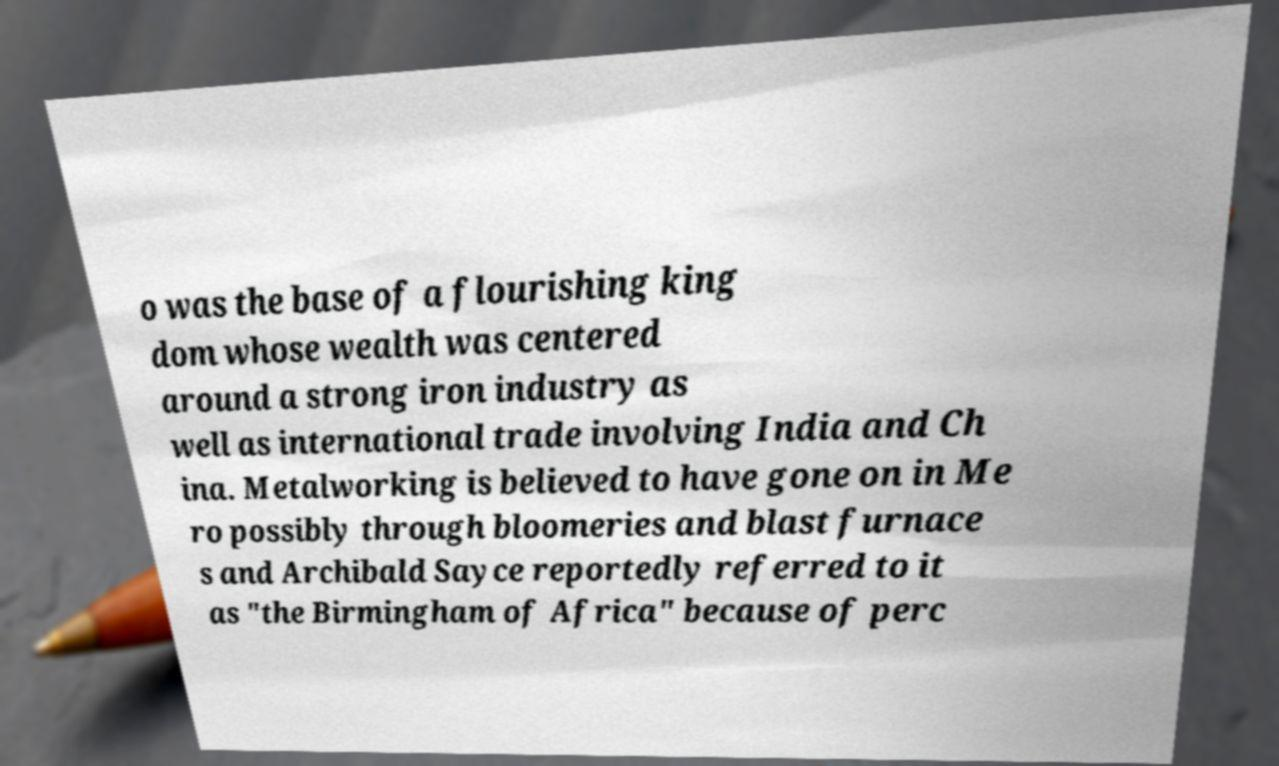Please identify and transcribe the text found in this image. o was the base of a flourishing king dom whose wealth was centered around a strong iron industry as well as international trade involving India and Ch ina. Metalworking is believed to have gone on in Me ro possibly through bloomeries and blast furnace s and Archibald Sayce reportedly referred to it as "the Birmingham of Africa" because of perc 